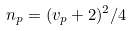Convert formula to latex. <formula><loc_0><loc_0><loc_500><loc_500>n _ { p } = ( v _ { p } + 2 ) ^ { 2 } / 4</formula> 